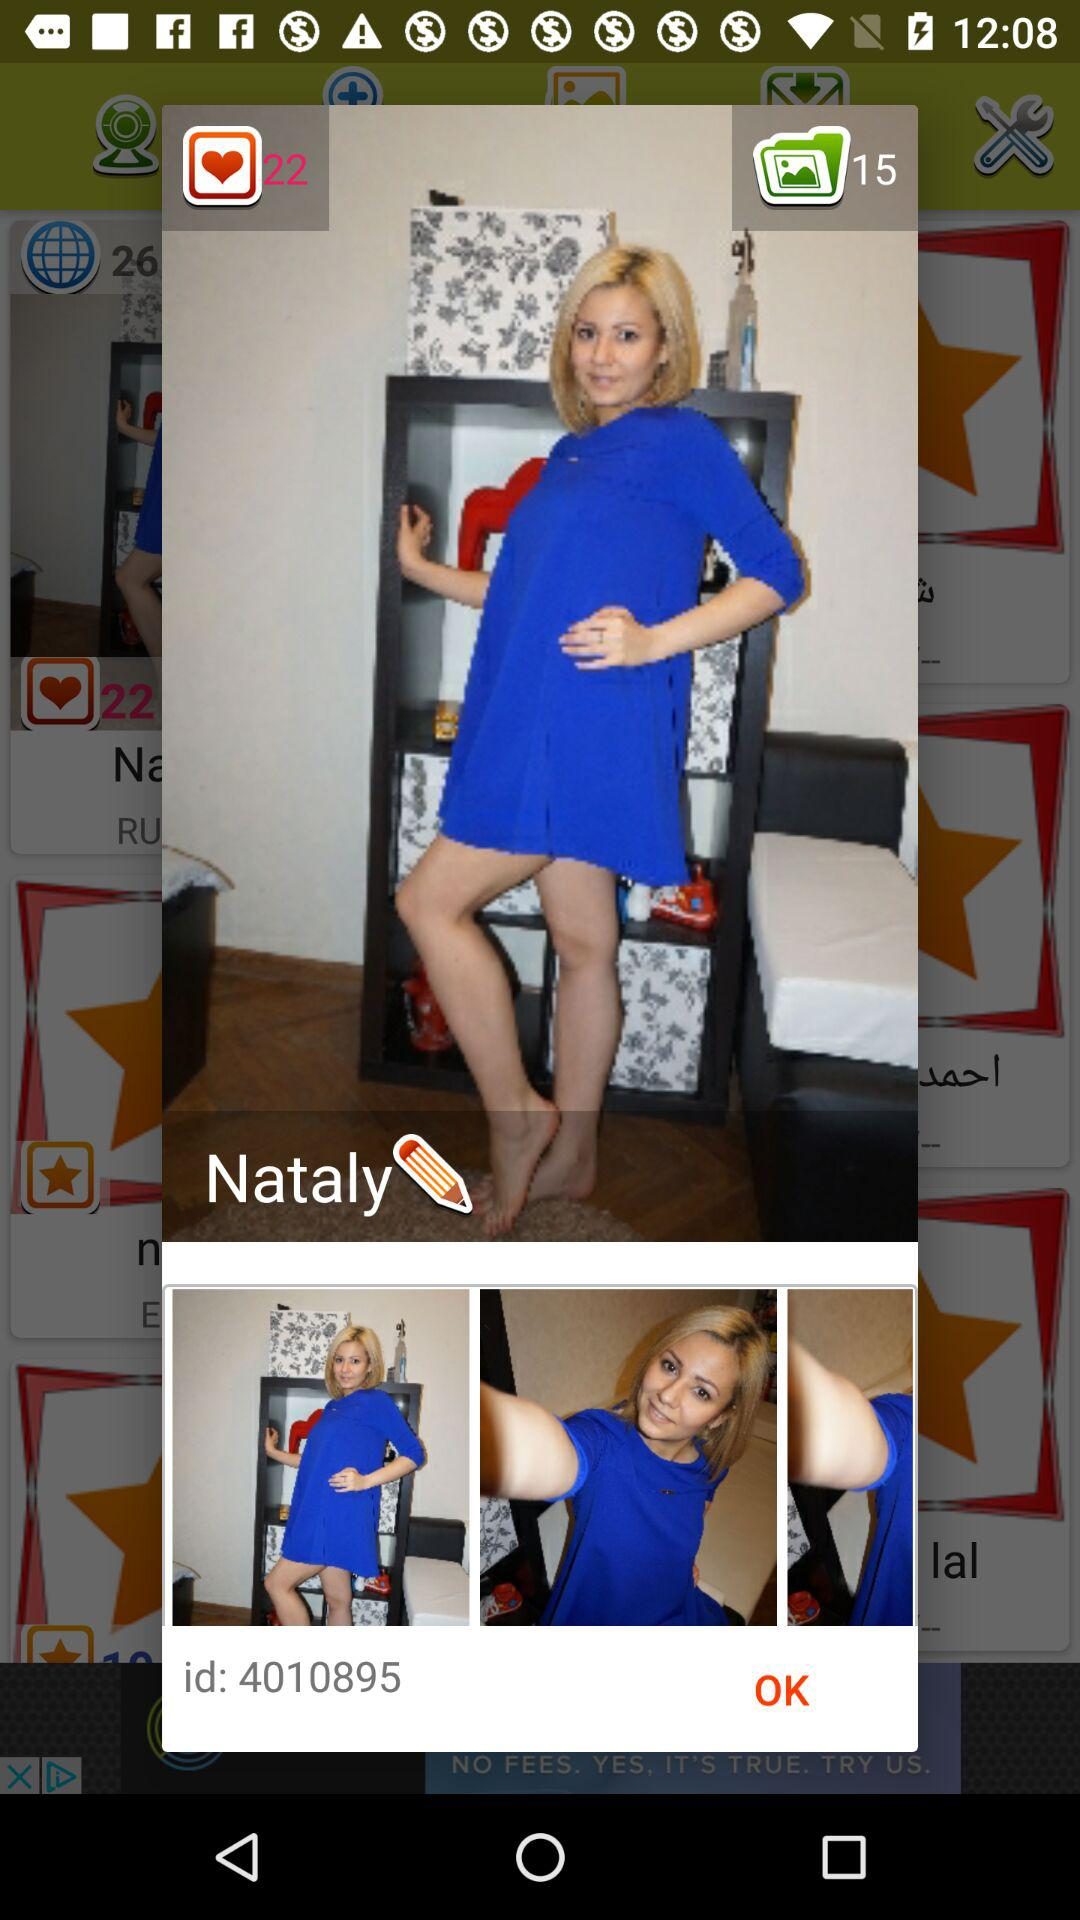What is the ID shown on the screen? The shown ID is 4010895. 